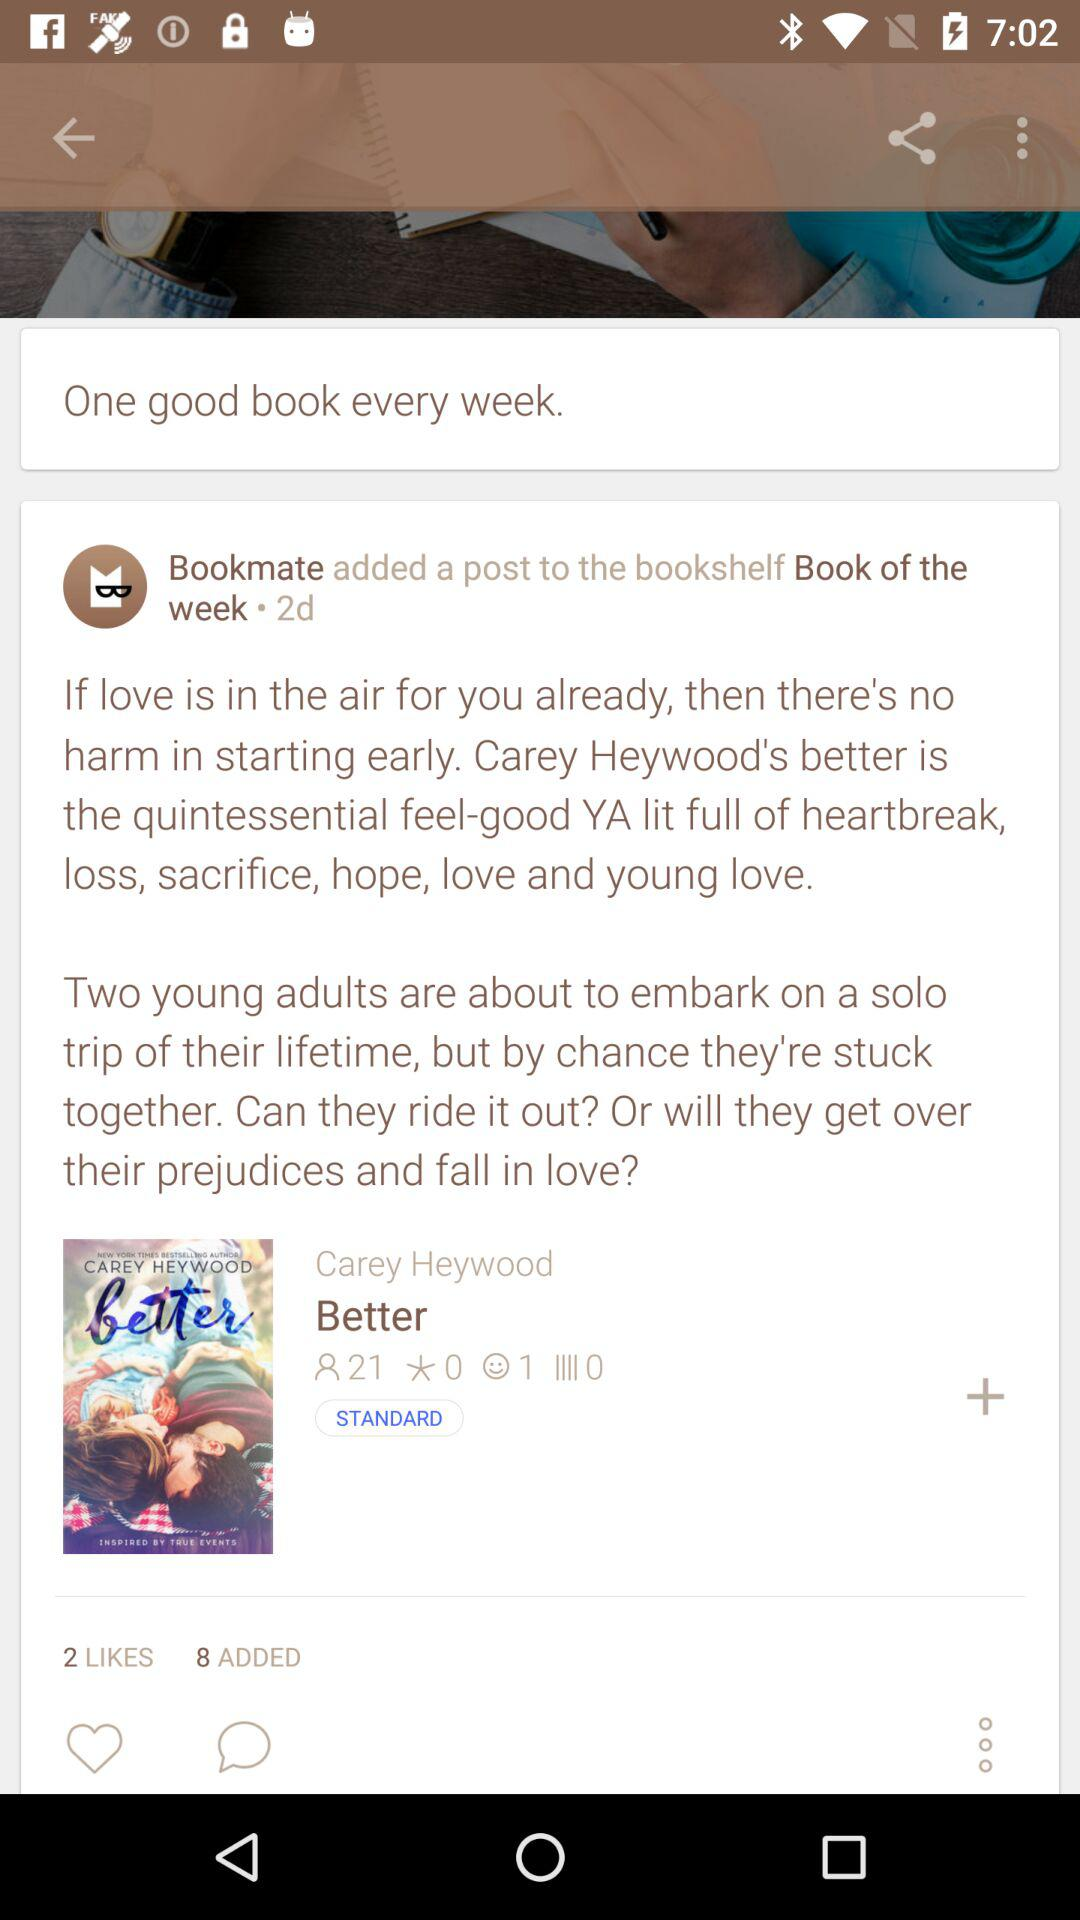How many more adds are there than likes?
Answer the question using a single word or phrase. 6 